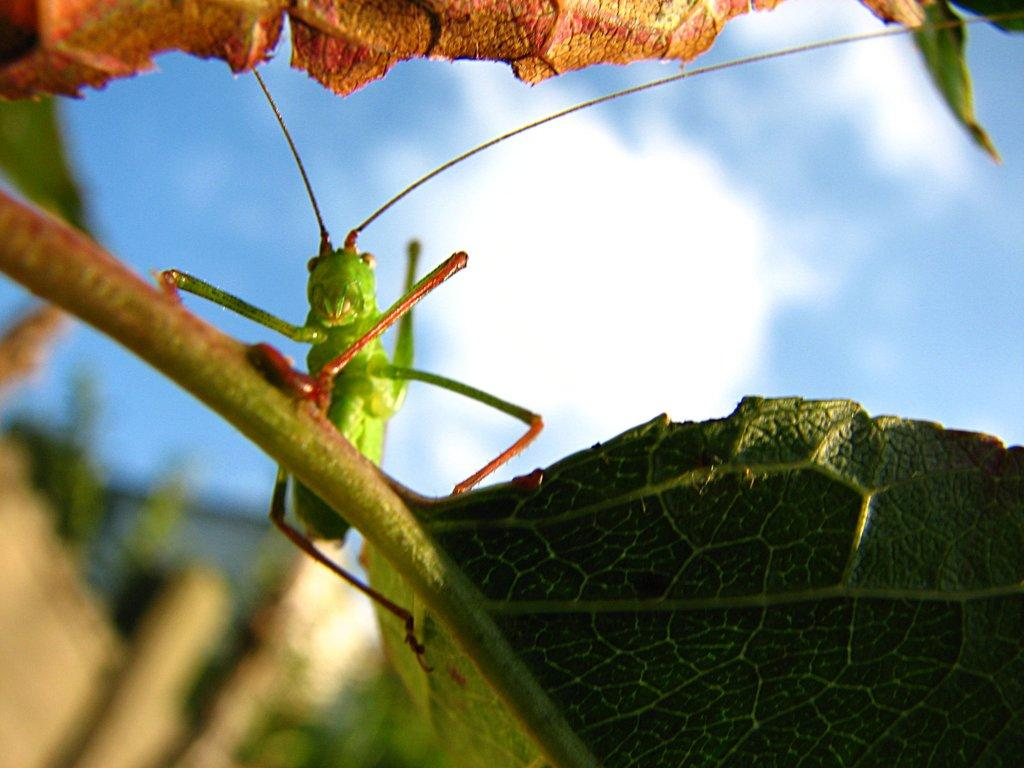What type of living organism can be seen in the image? There is an insect in the image. What other object is present in the image? There is a plant in the image. What can be seen in the sky in the image? Clouds are visible in the sky in the image. How many dolls are sitting on the plant in the image? There are no dolls present in the image; it features an insect and a plant. Can you tell me how many times the crow sneezes in the image? There is no crow present in the image, so it is not possible to determine how many times it sneezes. 